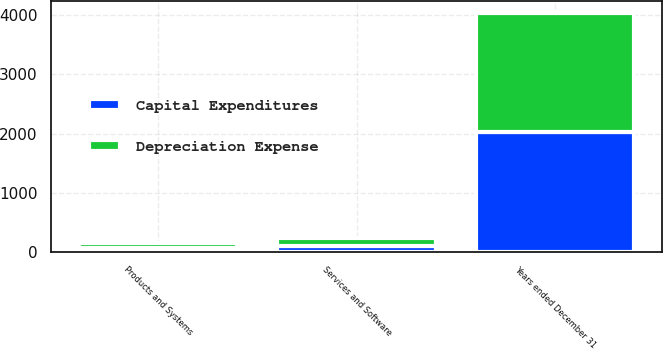Convert chart to OTSL. <chart><loc_0><loc_0><loc_500><loc_500><stacked_bar_chart><ecel><fcel>Years ended December 31<fcel>Products and Systems<fcel>Services and Software<nl><fcel>Depreciation Expense<fcel>2018<fcel>72<fcel>125<nl><fcel>Capital Expenditures<fcel>2018<fcel>71<fcel>101<nl></chart> 